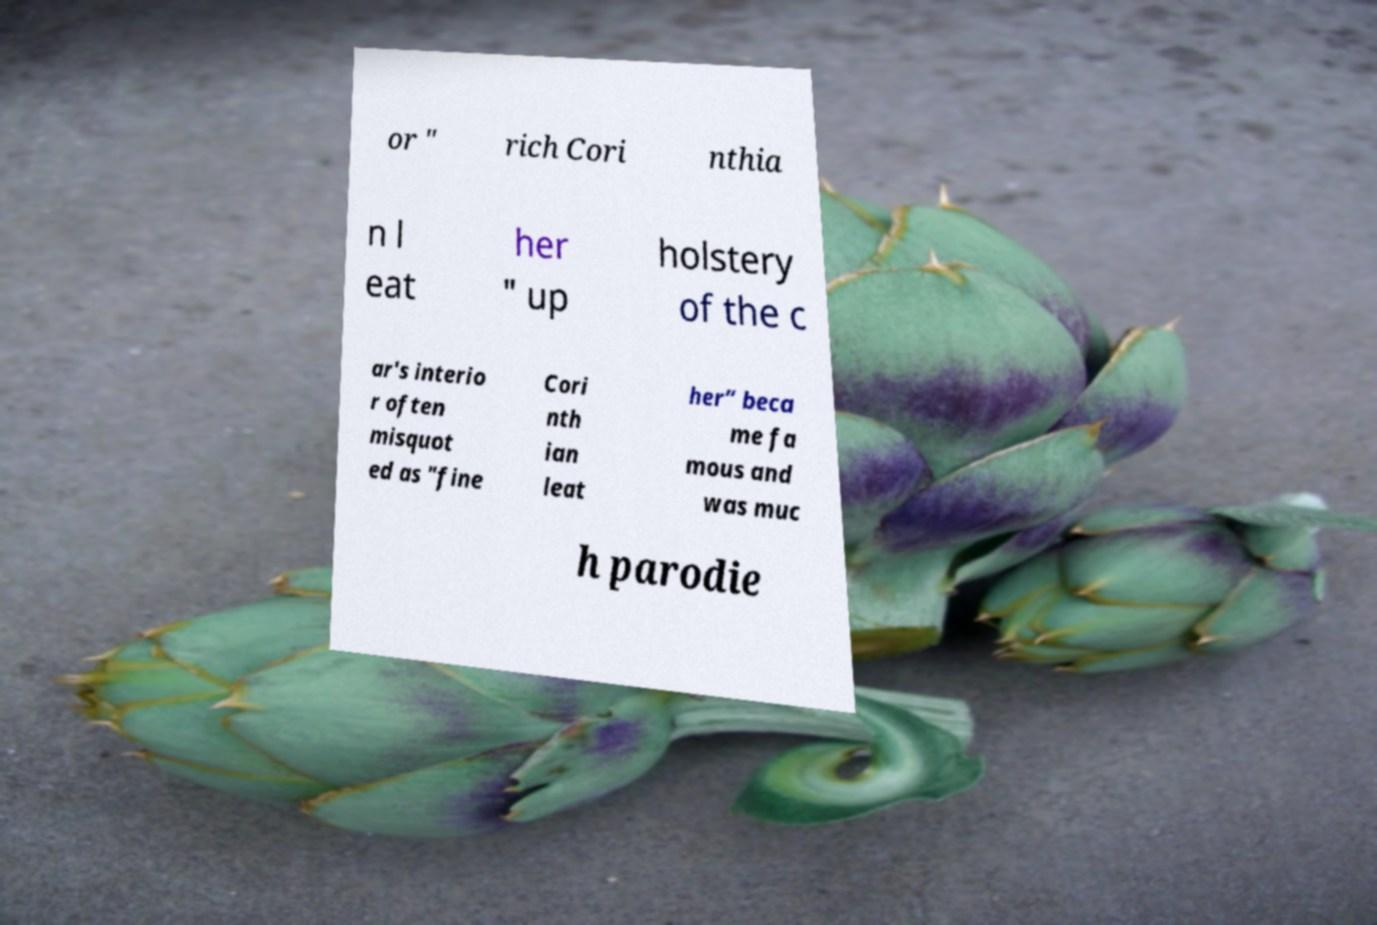I need the written content from this picture converted into text. Can you do that? or " rich Cori nthia n l eat her " up holstery of the c ar's interio r often misquot ed as "fine Cori nth ian leat her” beca me fa mous and was muc h parodie 